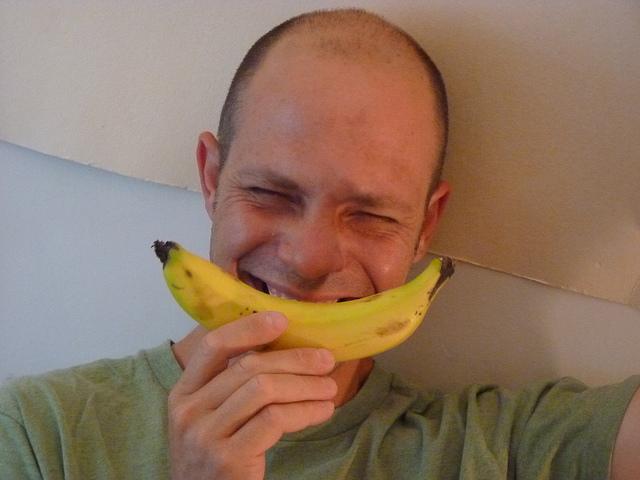Does the man wear glasses?
Write a very short answer. No. Does this man have lots of hair?
Keep it brief. No. IS this man's eyes open?
Give a very brief answer. No. What is the man portraying the banana to be?
Give a very brief answer. Smile. 